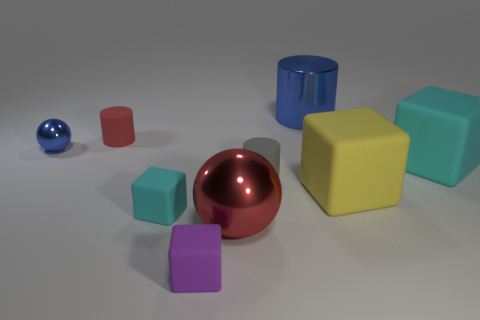Add 1 cyan rubber blocks. How many objects exist? 10 Subtract all tiny cyan matte blocks. How many blocks are left? 3 Subtract all blue cylinders. How many cylinders are left? 2 Subtract all cubes. How many objects are left? 5 Subtract 3 cylinders. How many cylinders are left? 0 Subtract all yellow cubes. Subtract all purple cylinders. How many cubes are left? 3 Subtract all cyan blocks. How many blue balls are left? 1 Subtract all large brown matte objects. Subtract all small matte cylinders. How many objects are left? 7 Add 1 big cyan blocks. How many big cyan blocks are left? 2 Add 9 tiny purple cubes. How many tiny purple cubes exist? 10 